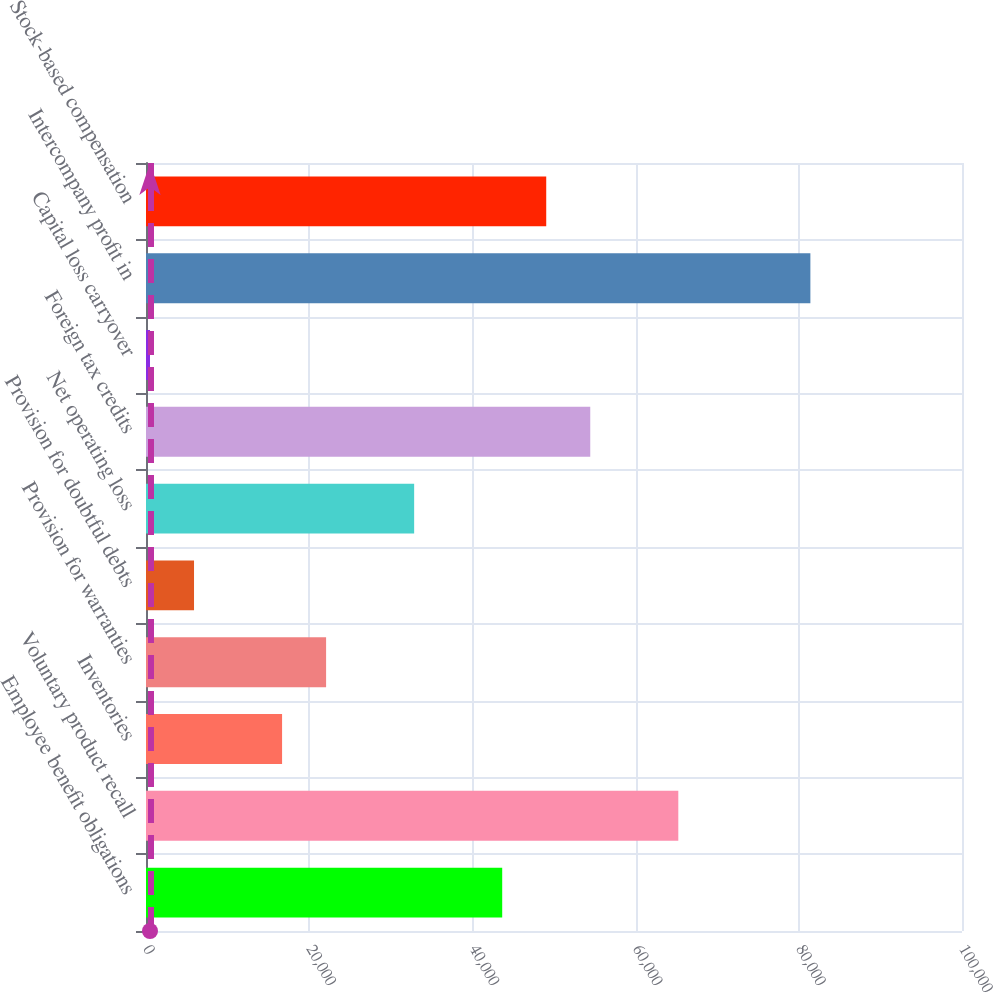Convert chart to OTSL. <chart><loc_0><loc_0><loc_500><loc_500><bar_chart><fcel>Employee benefit obligations<fcel>Voluntary product recall<fcel>Inventories<fcel>Provision for warranties<fcel>Provision for doubtful debts<fcel>Net operating loss<fcel>Foreign tax credits<fcel>Capital loss carryover<fcel>Intercompany profit in<fcel>Stock-based compensation<nl><fcel>43652.4<fcel>65233.6<fcel>16675.9<fcel>22071.2<fcel>5885.3<fcel>32861.8<fcel>54443<fcel>490<fcel>81419.5<fcel>49047.7<nl></chart> 